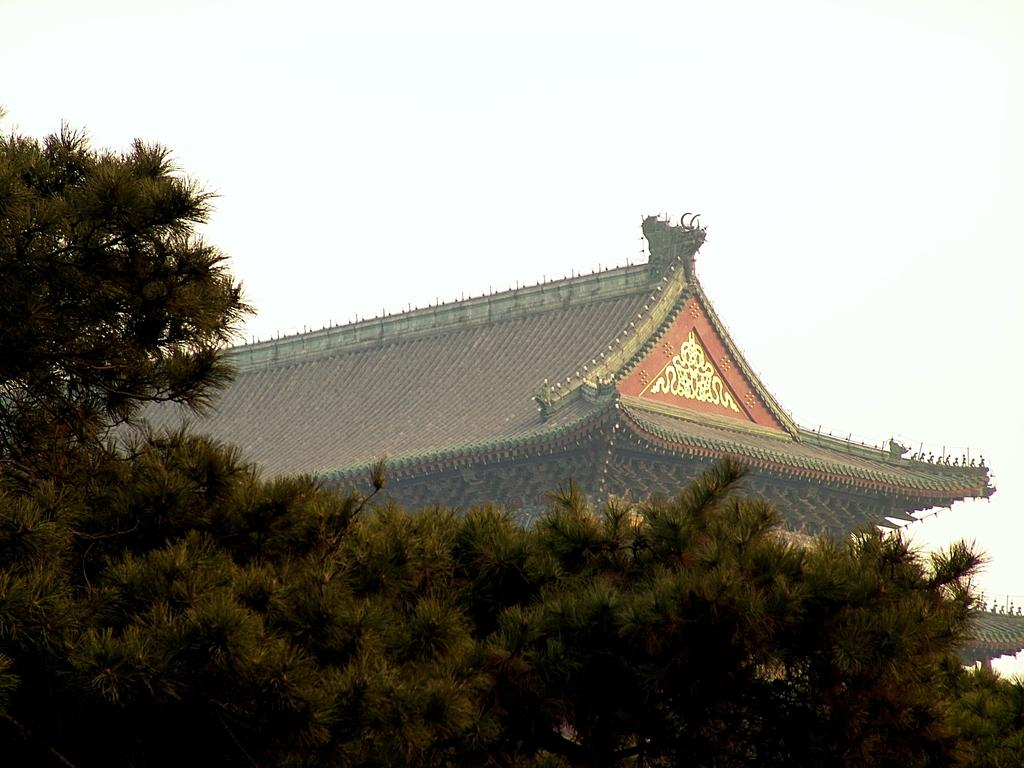What type of vegetation is at the bottom of the image? There are trees at the bottom of the image. What structure can be seen in the background of the image? There is a roof visible in the background of the image. What is visible in the sky in the background of the image? Clouds are present in the sky in the background of the image. Can you see a ghost offering a change in the image? There is no ghost or any indication of an offer or change in the image. 